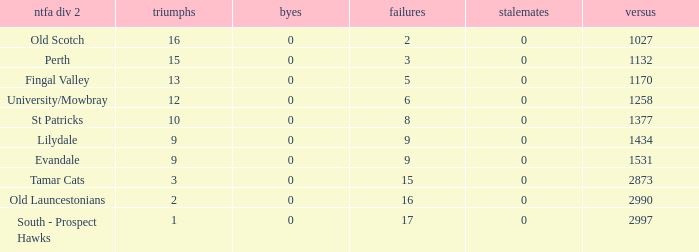Can you parse all the data within this table? {'header': ['ntfa div 2', 'triumphs', 'byes', 'failures', 'stalemates', 'versus'], 'rows': [['Old Scotch', '16', '0', '2', '0', '1027'], ['Perth', '15', '0', '3', '0', '1132'], ['Fingal Valley', '13', '0', '5', '0', '1170'], ['University/Mowbray', '12', '0', '6', '0', '1258'], ['St Patricks', '10', '0', '8', '0', '1377'], ['Lilydale', '9', '0', '9', '0', '1434'], ['Evandale', '9', '0', '9', '0', '1531'], ['Tamar Cats', '3', '0', '15', '0', '2873'], ['Old Launcestonians', '2', '0', '16', '0', '2990'], ['South - Prospect Hawks', '1', '0', '17', '0', '2997']]} What is the lowest number of draws of the team with 9 wins and less than 0 byes? None. 